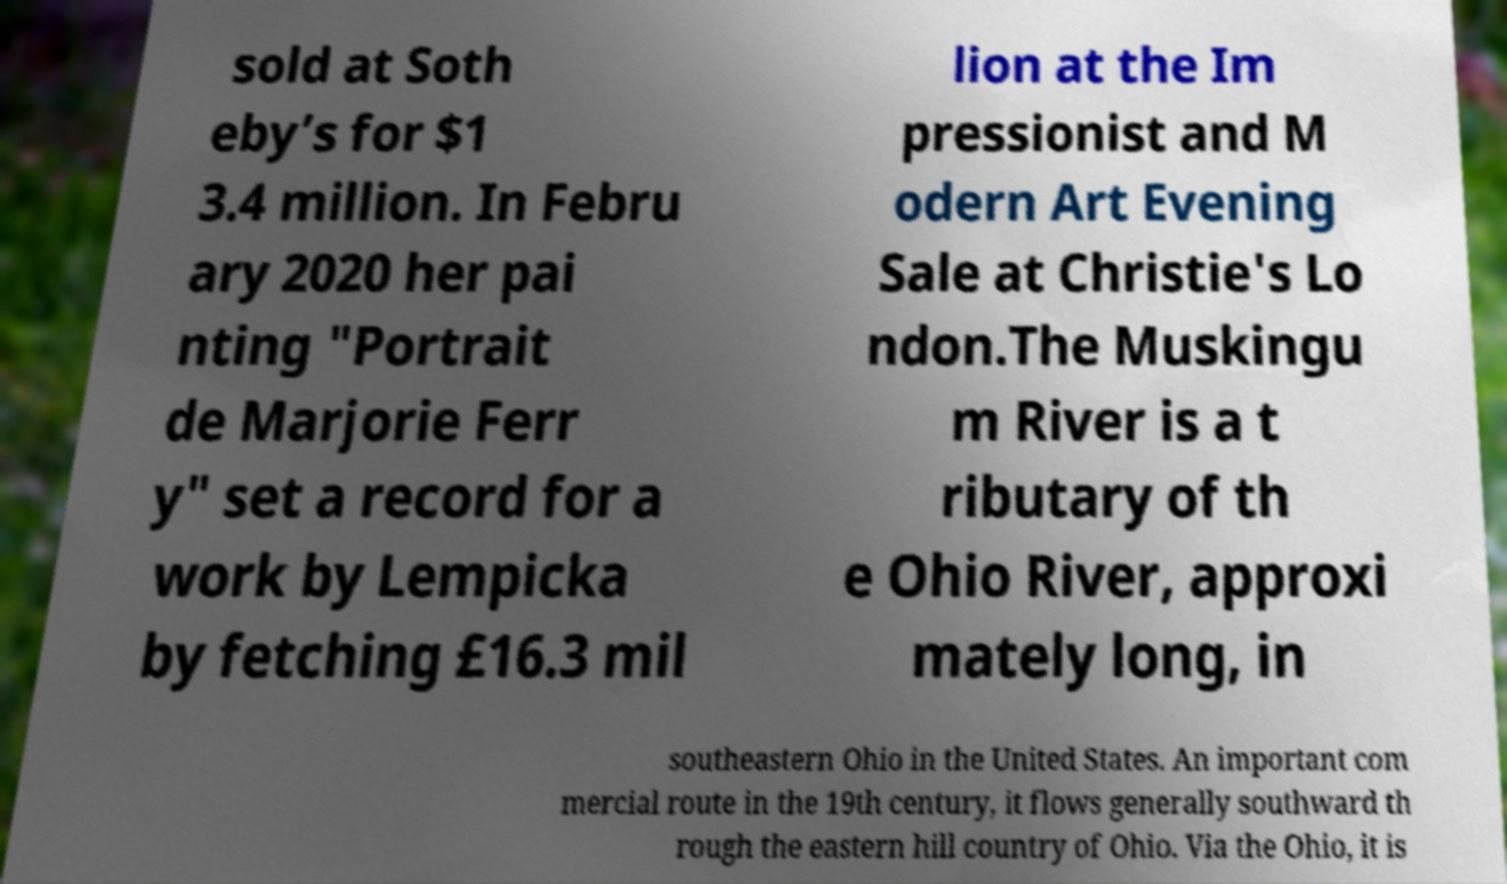Can you read and provide the text displayed in the image?This photo seems to have some interesting text. Can you extract and type it out for me? sold at Soth eby’s for $1 3.4 million. In Febru ary 2020 her pai nting "Portrait de Marjorie Ferr y" set a record for a work by Lempicka by fetching £16.3 mil lion at the Im pressionist and M odern Art Evening Sale at Christie's Lo ndon.The Muskingu m River is a t ributary of th e Ohio River, approxi mately long, in southeastern Ohio in the United States. An important com mercial route in the 19th century, it flows generally southward th rough the eastern hill country of Ohio. Via the Ohio, it is 